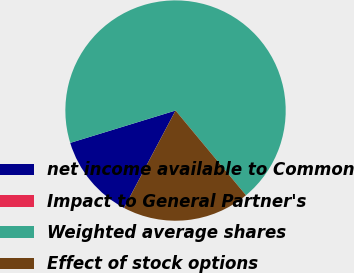Convert chart to OTSL. <chart><loc_0><loc_0><loc_500><loc_500><pie_chart><fcel>net income available to Common<fcel>Impact to General Partner's<fcel>Weighted average shares<fcel>Effect of stock options<nl><fcel>12.52%<fcel>0.0%<fcel>68.7%<fcel>18.78%<nl></chart> 